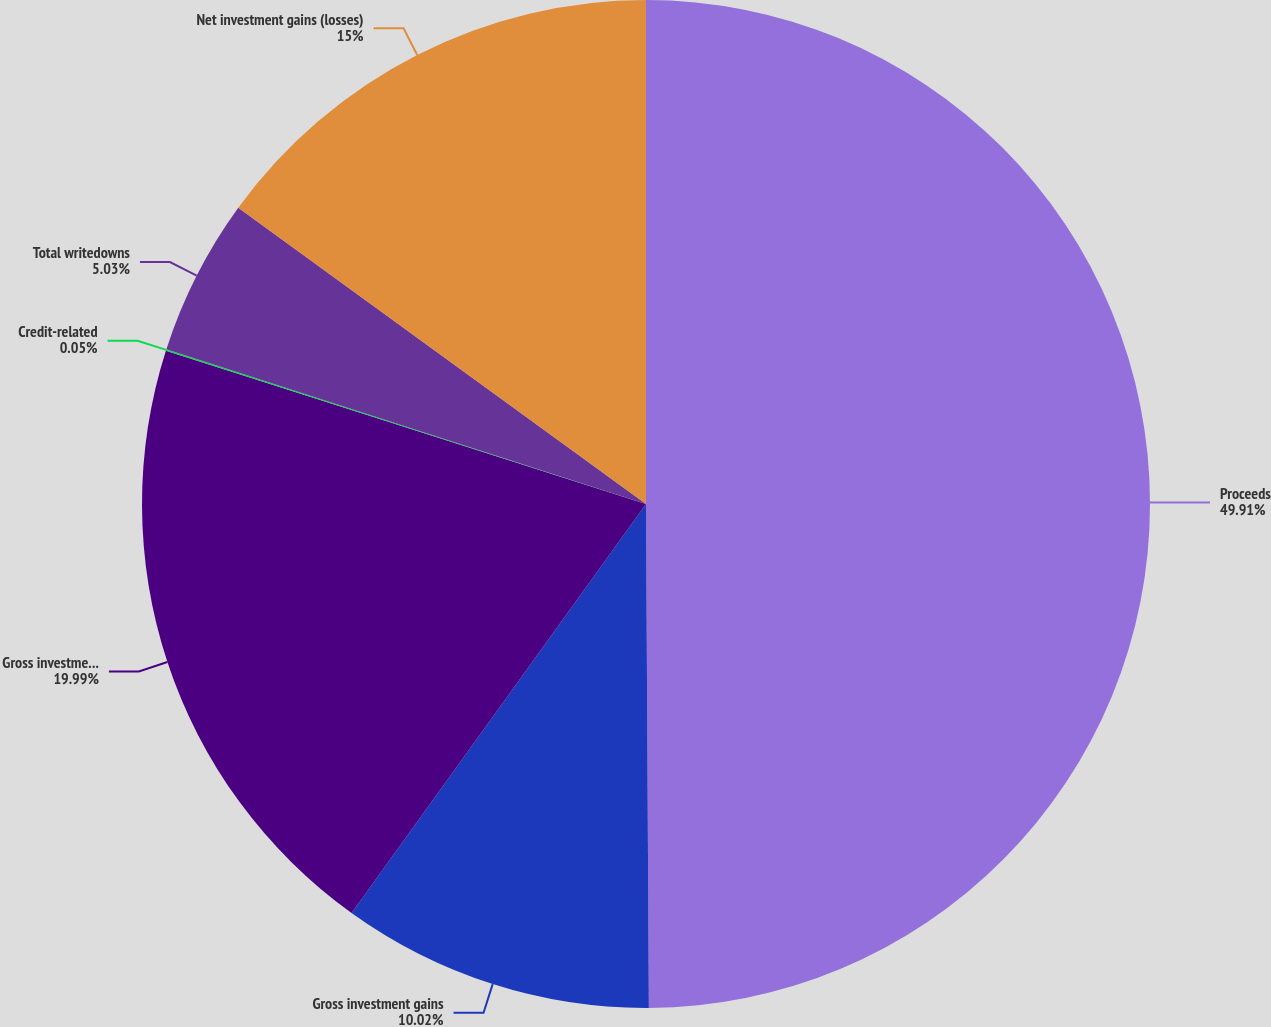Convert chart. <chart><loc_0><loc_0><loc_500><loc_500><pie_chart><fcel>Proceeds<fcel>Gross investment gains<fcel>Gross investment losses<fcel>Credit-related<fcel>Total writedowns<fcel>Net investment gains (losses)<nl><fcel>49.91%<fcel>10.02%<fcel>19.99%<fcel>0.05%<fcel>5.03%<fcel>15.0%<nl></chart> 